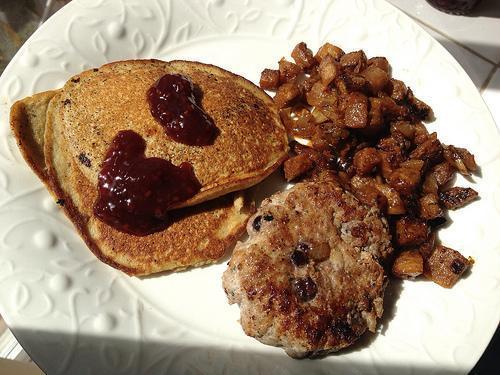How many different kinds of food are on the plate?
Give a very brief answer. 3. How many pancakes are on the plate?
Give a very brief answer. 3. How many different types of food are on the plate?
Give a very brief answer. 3. How many people are pictured here?
Give a very brief answer. 0. How many animals are in the photo?
Give a very brief answer. 0. 